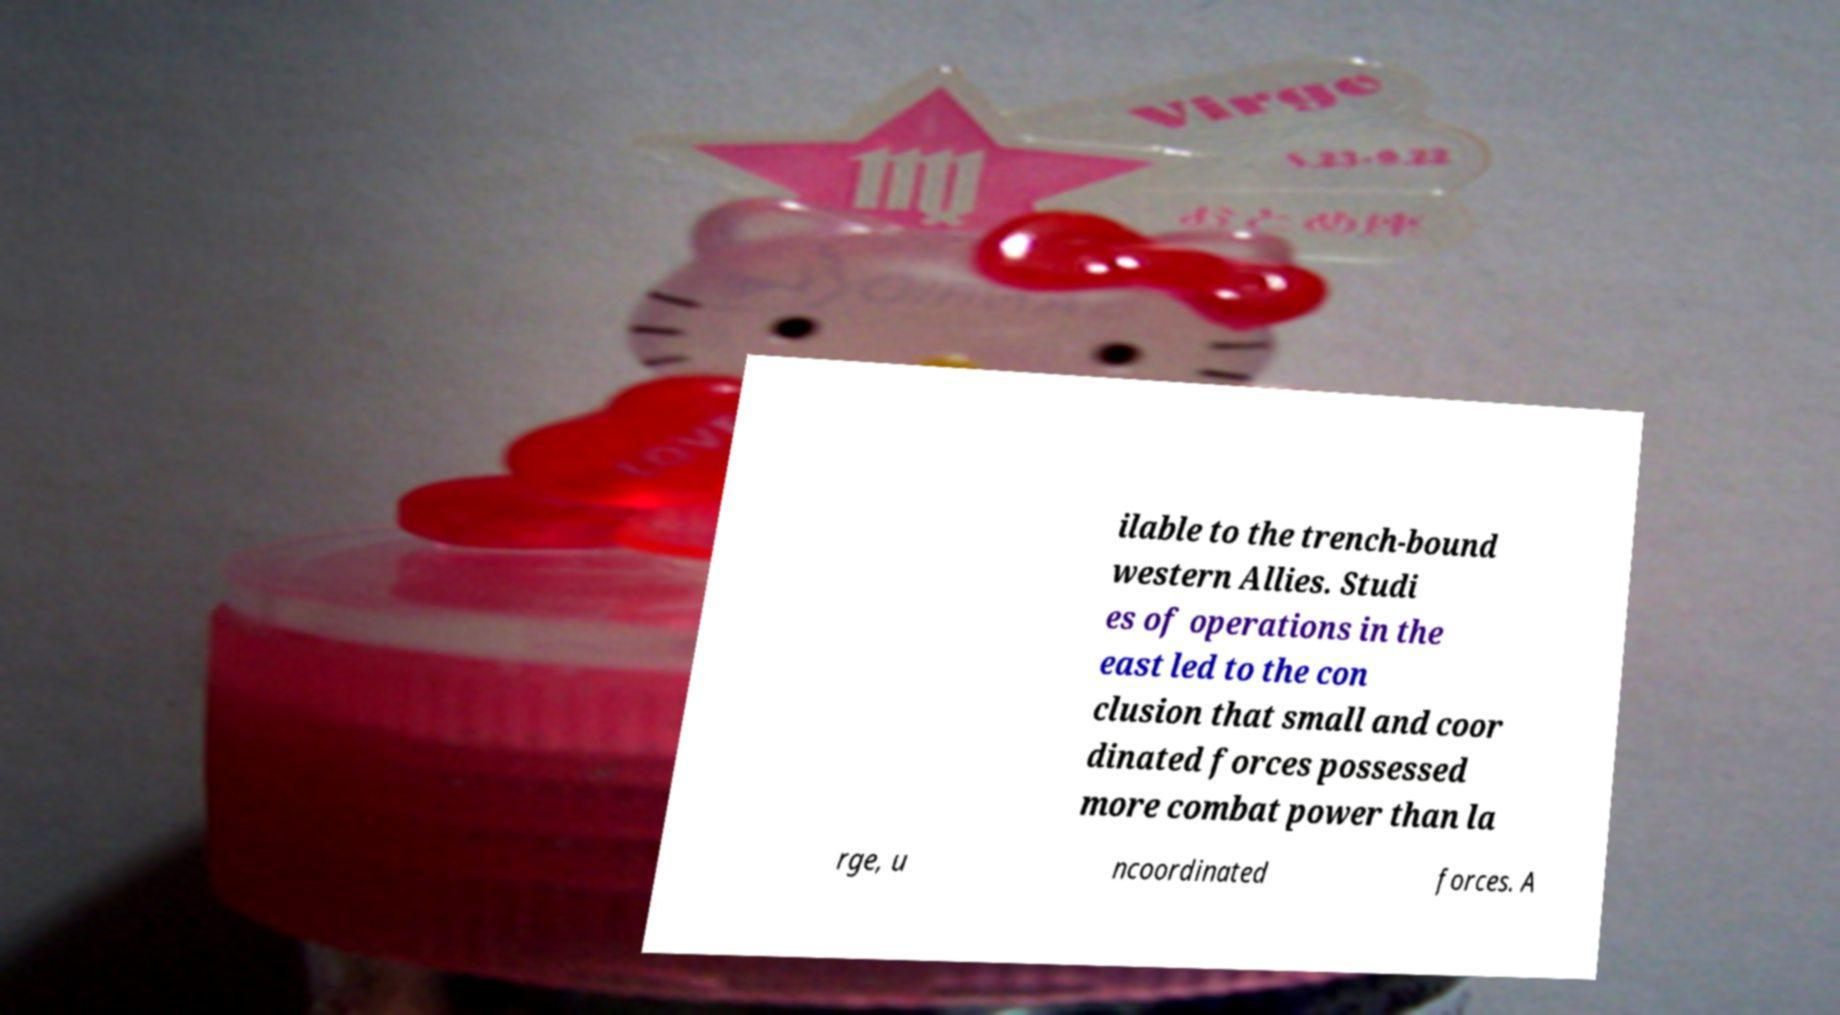Could you extract and type out the text from this image? ilable to the trench-bound western Allies. Studi es of operations in the east led to the con clusion that small and coor dinated forces possessed more combat power than la rge, u ncoordinated forces. A 